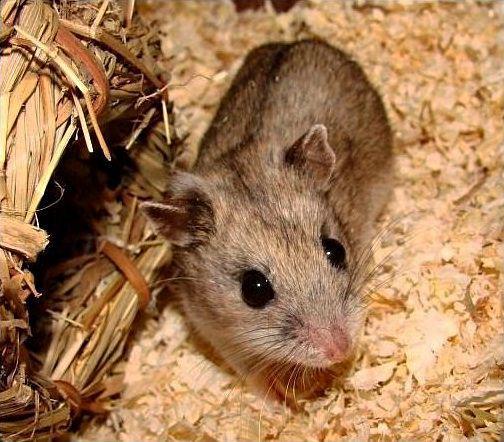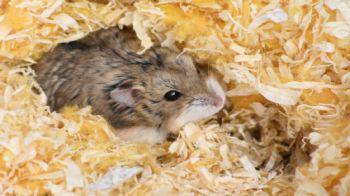The first image is the image on the left, the second image is the image on the right. Examine the images to the left and right. Is the description "There are two rodents in the image on the right." accurate? Answer yes or no. No. The first image is the image on the left, the second image is the image on the right. Evaluate the accuracy of this statement regarding the images: "The right image contains exactly two mouse-like animals posed side-by-side with heads close together, and the left image contains something round and brown that nearly fills the space.". Is it true? Answer yes or no. No. 